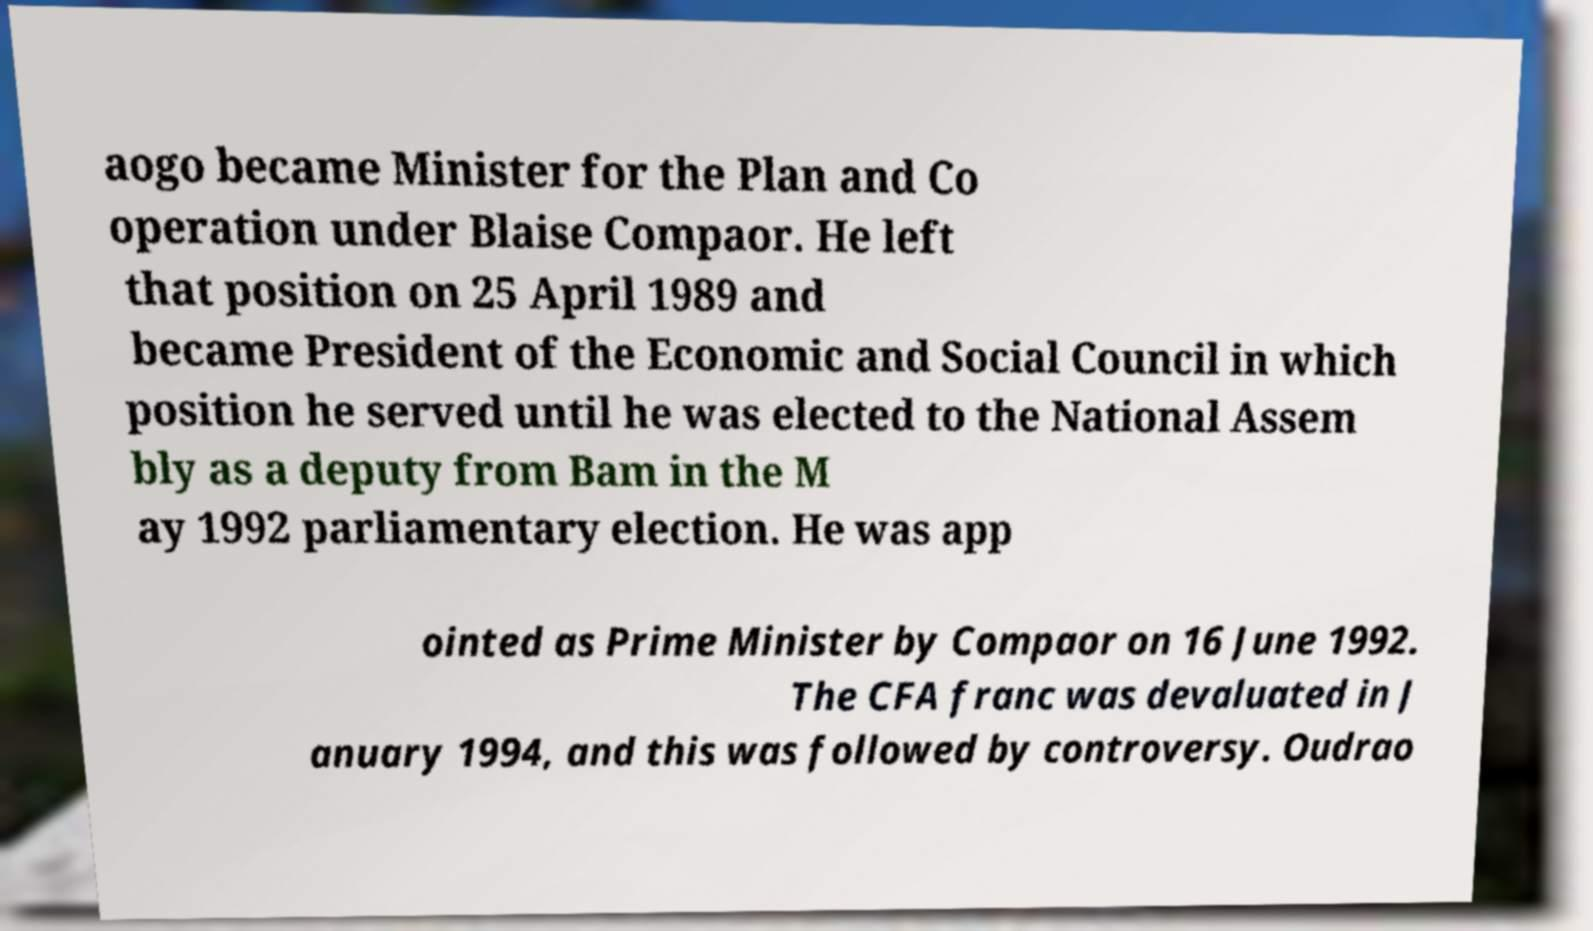What messages or text are displayed in this image? I need them in a readable, typed format. aogo became Minister for the Plan and Co operation under Blaise Compaor. He left that position on 25 April 1989 and became President of the Economic and Social Council in which position he served until he was elected to the National Assem bly as a deputy from Bam in the M ay 1992 parliamentary election. He was app ointed as Prime Minister by Compaor on 16 June 1992. The CFA franc was devaluated in J anuary 1994, and this was followed by controversy. Oudrao 